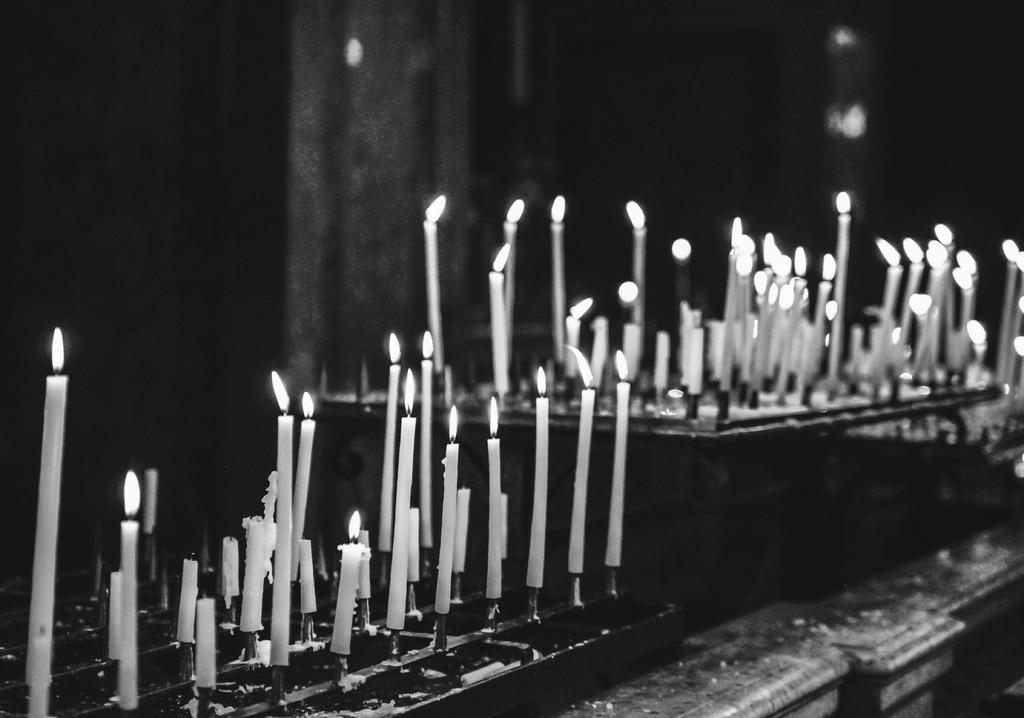What type of furniture is present in the image? There is a desk and another table in the image. What is on the desk in the image? There are candles with fire on the desk. What is on the other table in the image? There are candles with fire on the other table. What type of box is used to store the fan in the image? There is no box or fan present in the image. What do you believe the purpose of the candles is in the image? The purpose of the candles cannot be determined from the image alone, but they may be used for lighting or decoration. 